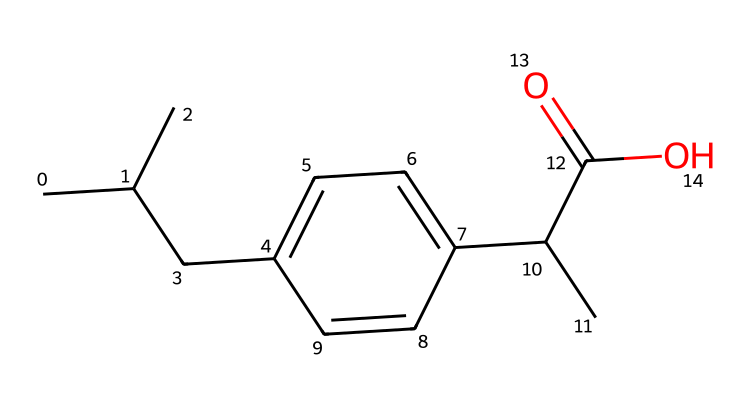What is the main functional group present in this chemical? The chemical meets the definition of a carboxylic acid, which is characterized by the presence of a carboxyl group (-COOH) that can be seen in the structure.
Answer: carboxylic acid How many carbon atoms are in this chemical? Counting the carbon atoms represented in the structure reveals a total of 12 carbon atoms connected together in various configurations.
Answer: 12 What type of compound is represented by this SMILES? The presence of the carboxylic acid functional group along with a complex structure suggests that this compound is an anti-inflammatory drug, which fits the criteria of a nonsteroidal anti-inflammatory drug (NSAID).
Answer: NSAID What is the oxidation state of the carbon in the carboxylic acid group? In the carboxylic acid group (-COOH), the carbon atom is bonded to both a hydroxyl group (-OH) and a carbonyl group (C=O), leading to an oxidation state of +3 for that carbon.
Answer: +3 Does this drug have a potential for gastrointestinal side effects? Given that many nonsteroidal anti-inflammatory drugs, including those with a similar structure, are known to cause gastrointestinal issues as a side effect, it is reasonable to conclude that this compound may also have that potential based on its classification.
Answer: Yes 